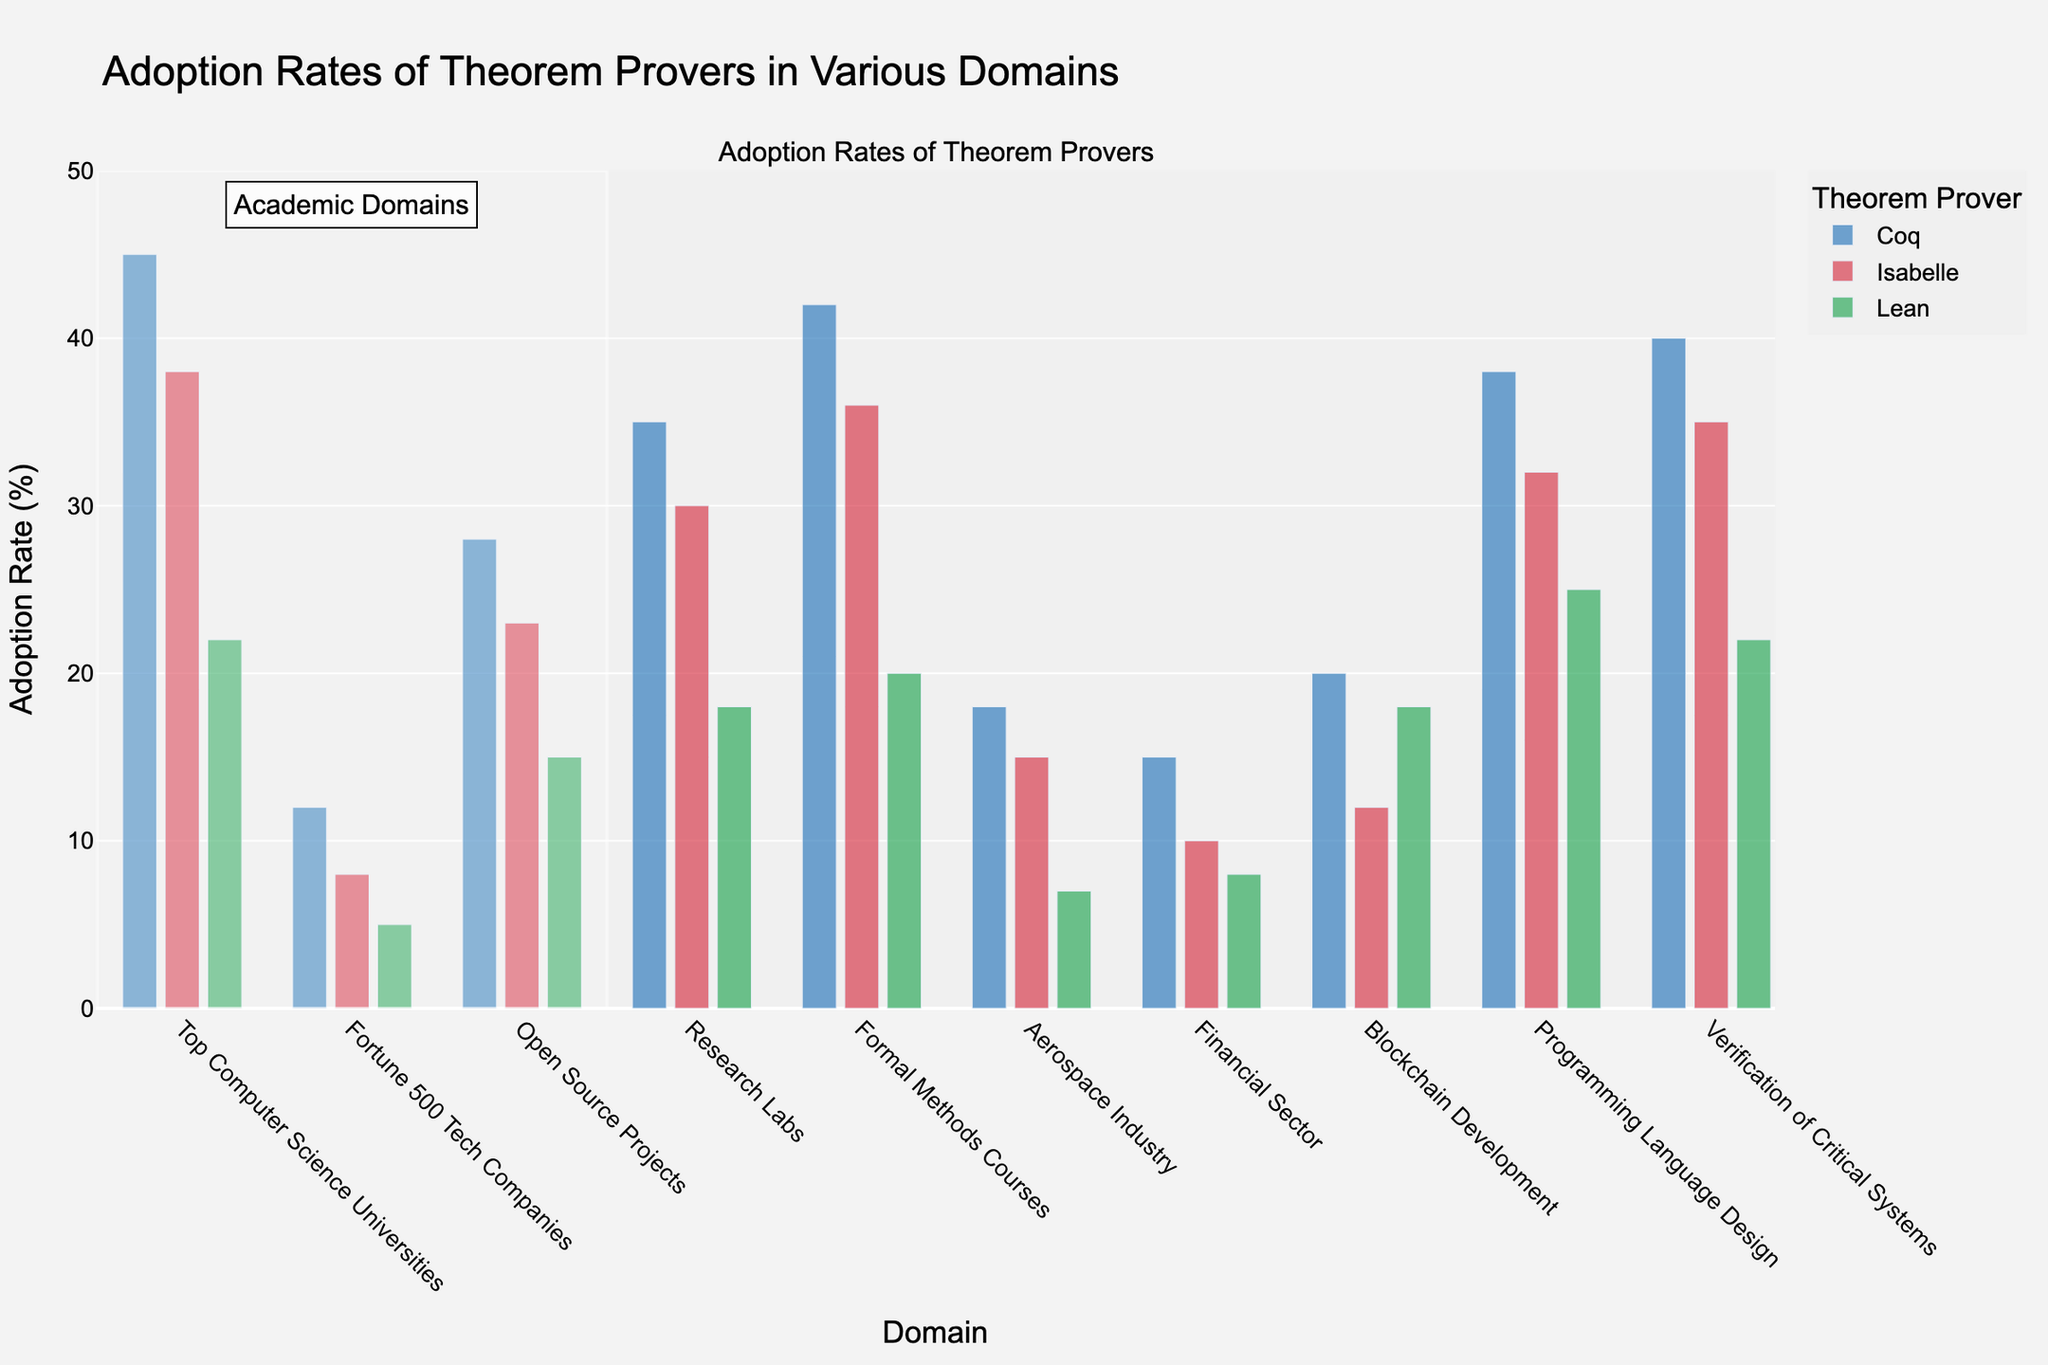What's the highest adoption rate for Coq, and in which domain does it occur? From the bar chart, look for the tallest bar corresponding to Coq (blue bars). Coq has the highest adoption rate in "Top Computer Science Universities" with 45%.
Answer: 45% in Top Computer Science Universities Comparing Coq and Lean, which theorem prover has higher adoption in the Financial Sector, and by how much? Compare the heights of the bars for Coq (blue) and Lean (green) in the Financial Sector. Coq has an adoption rate of 15%, while Lean has 8%, so Coq is higher by 7%.
Answer: Coq by 7% What is the combined adoption rate of Isabelle in Formal Methods Courses and Research Labs? Identify the heights of the red bars for Isabelle in both "Formal Methods Courses" and "Research Labs." The rates are 36% and 30%, respectively. Sum these values: 36 + 30 = 66%.
Answer: 66% Is Lean’s adoption rate in Programming Language Design higher or lower than in Blockchain Development, and by how much? Compare the green bars for Lean in "Programming Language Design" (25%) and "Blockchain Development" (18%). The rate in "Programming Language Design" is higher by 7%.
Answer: Higher by 7% In which domain does Lean have the lowest adoption rate, and what is this rate? Look for the shortest green bar across all domains. Lean has the lowest adoption rate in the Aerospace Industry at 7%.
Answer: Aerospace Industry at 7% Calculate the average adoption rate of Isabelle in all the given domains. Sum up the adoption rates for Isabelle: 38 + 8 + 23 + 30 + 36 + 15 + 10 + 12 + 32 + 35 = 239. Count the domains (10). Divide the total by the number of domains: 239 / 10 = 23.9%.
Answer: 23.9% Which theorem prover has the most significant difference in adoption rate between Formal Methods Courses and the Financial Sector? Calculate the differences for each theorem prover: Coq: 42 - 15 = 27%, Isabelle: 36 - 10 = 26%, Lean: 20 - 8 = 12%. Coq shows the largest difference of 27%.
Answer: Coq with 27% Between Coq, Isabelle, and Lean, which theorem prover is most uniformly adopted across the different domains, and how can you tell? Assess the consistency of bar heights for each theorem prover across all domains. Isabelle’s bar heights are more uniform, ranging between 8% and 38%. In contrast, Coq ranges from 12% to 45%, and Lean ranges from 5% to 25%.
Answer: Isabelle In terms of adoption rates, which theorem prover is the most popular in Open Source Projects, and what is the rate? Compare the heights of bars in "Open Source Projects" for Coq, Isabelle, and Lean. Coq has the highest adoption rate at 28%.
Answer: Coq at 28% What is the total adoption rate for all theorem provers in Blockchain Development? Sum the adoption rates for Coq (20%), Isabelle (12%), and Lean (18%) in Blockchain Development: 20 + 12 + 18 = 50%.
Answer: 50% 